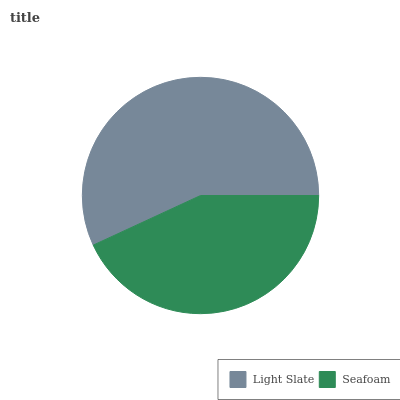Is Seafoam the minimum?
Answer yes or no. Yes. Is Light Slate the maximum?
Answer yes or no. Yes. Is Seafoam the maximum?
Answer yes or no. No. Is Light Slate greater than Seafoam?
Answer yes or no. Yes. Is Seafoam less than Light Slate?
Answer yes or no. Yes. Is Seafoam greater than Light Slate?
Answer yes or no. No. Is Light Slate less than Seafoam?
Answer yes or no. No. Is Light Slate the high median?
Answer yes or no. Yes. Is Seafoam the low median?
Answer yes or no. Yes. Is Seafoam the high median?
Answer yes or no. No. Is Light Slate the low median?
Answer yes or no. No. 